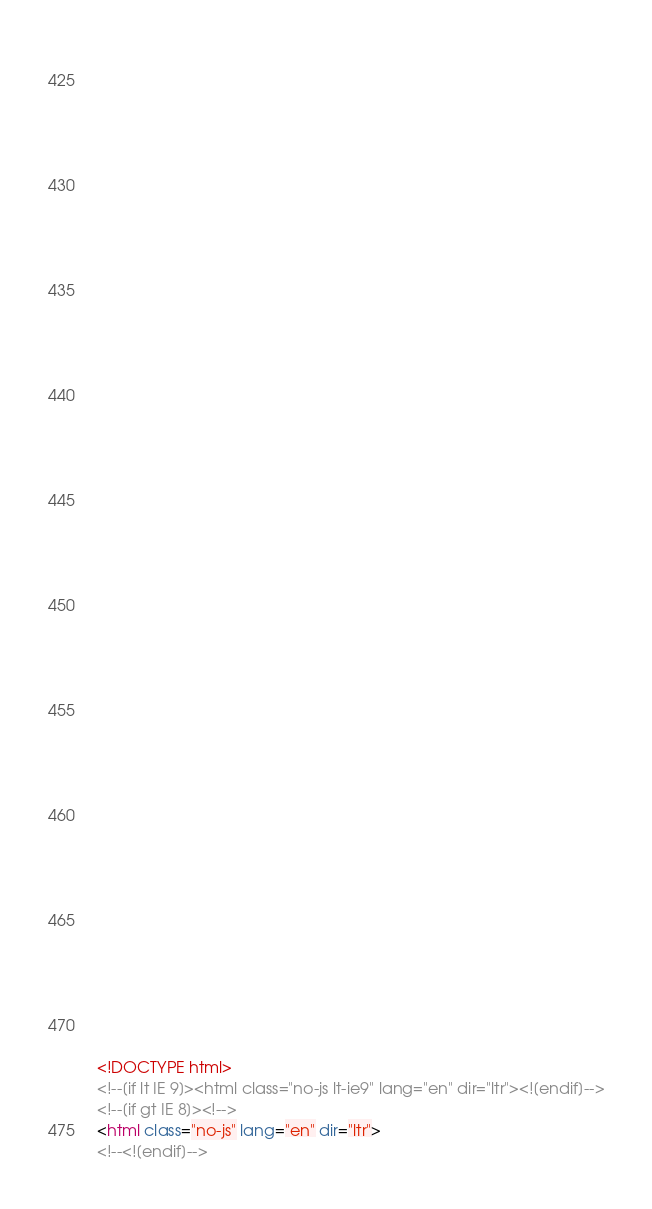Convert code to text. <code><loc_0><loc_0><loc_500><loc_500><_HTML_>


















	






  
  
  
  































	
	
	



<!DOCTYPE html>
<!--[if lt IE 9]><html class="no-js lt-ie9" lang="en" dir="ltr"><![endif]-->
<!--[if gt IE 8]><!-->
<html class="no-js" lang="en" dir="ltr">
<!--<![endif]-->

</code> 